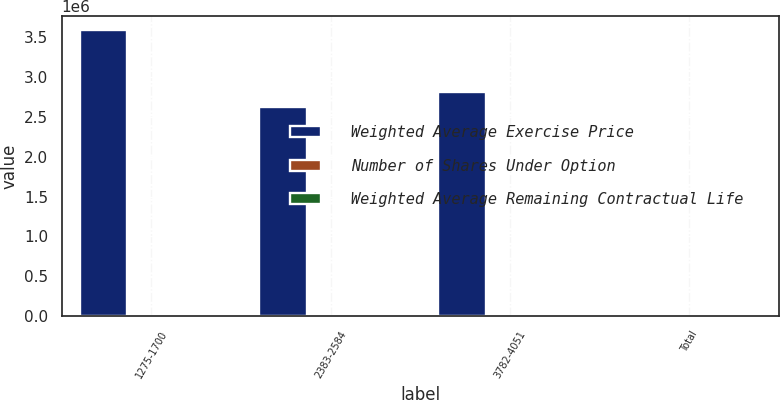Convert chart. <chart><loc_0><loc_0><loc_500><loc_500><stacked_bar_chart><ecel><fcel>1275-1700<fcel>2383-2584<fcel>3782-4051<fcel>Total<nl><fcel>Weighted Average Exercise Price<fcel>3.58661e+06<fcel>2.62664e+06<fcel>2.81298e+06<fcel>24.98<nl><fcel>Number of Shares Under Option<fcel>6<fcel>7<fcel>8<fcel>8<nl><fcel>Weighted Average Remaining Contractual Life<fcel>15.61<fcel>24.98<fcel>37.84<fcel>34.58<nl></chart> 